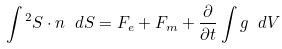<formula> <loc_0><loc_0><loc_500><loc_500>\int { ^ { 2 } S \cdot n } \ d S = F _ { e } + F _ { m } + \frac { \partial } { \partial t } \int g \ d V</formula> 